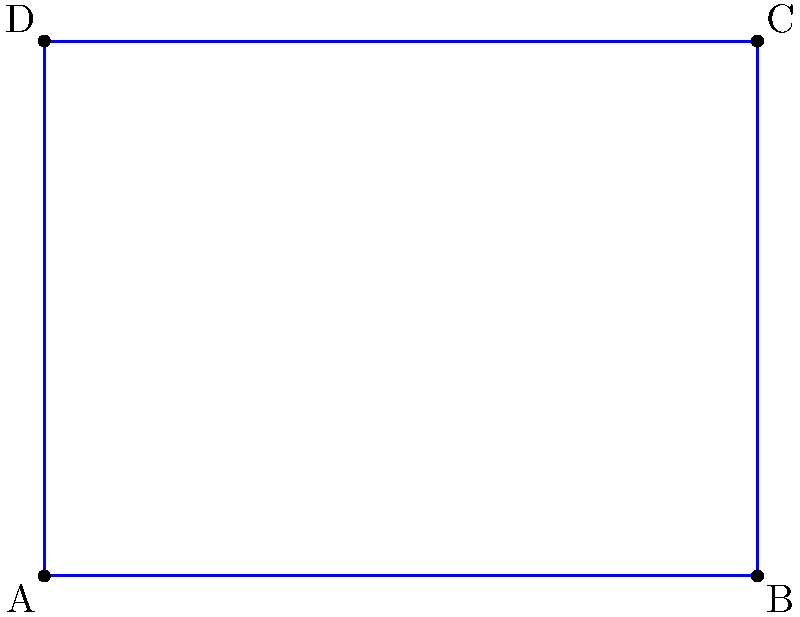As a soccer agent, you're negotiating a contract for a new stadium. The architects have provided you with a coordinate system representation of the soccer field. The vertices of the rectangular field are located at A(-6,0), B(6,0), C(6,9), and D(-6,9). Calculate the area of the soccer field in square units. To calculate the area of the rectangular soccer field, we need to follow these steps:

1) Identify the length and width of the field:
   - Length: distance between points A and B (or D and C)
   - Width: distance between points A and D (or B and C)

2) Calculate the length:
   Length = $|x_B - x_A|$ = $|6 - (-6)|$ = $|12|$ = 12 units

3) Calculate the width:
   Width = $|y_D - y_A|$ = $|9 - 0|$ = 9 units

4) Apply the formula for the area of a rectangle:
   Area = Length × Width
   Area = 12 × 9 = 108 square units

Therefore, the area of the soccer field is 108 square units.
Answer: 108 square units 